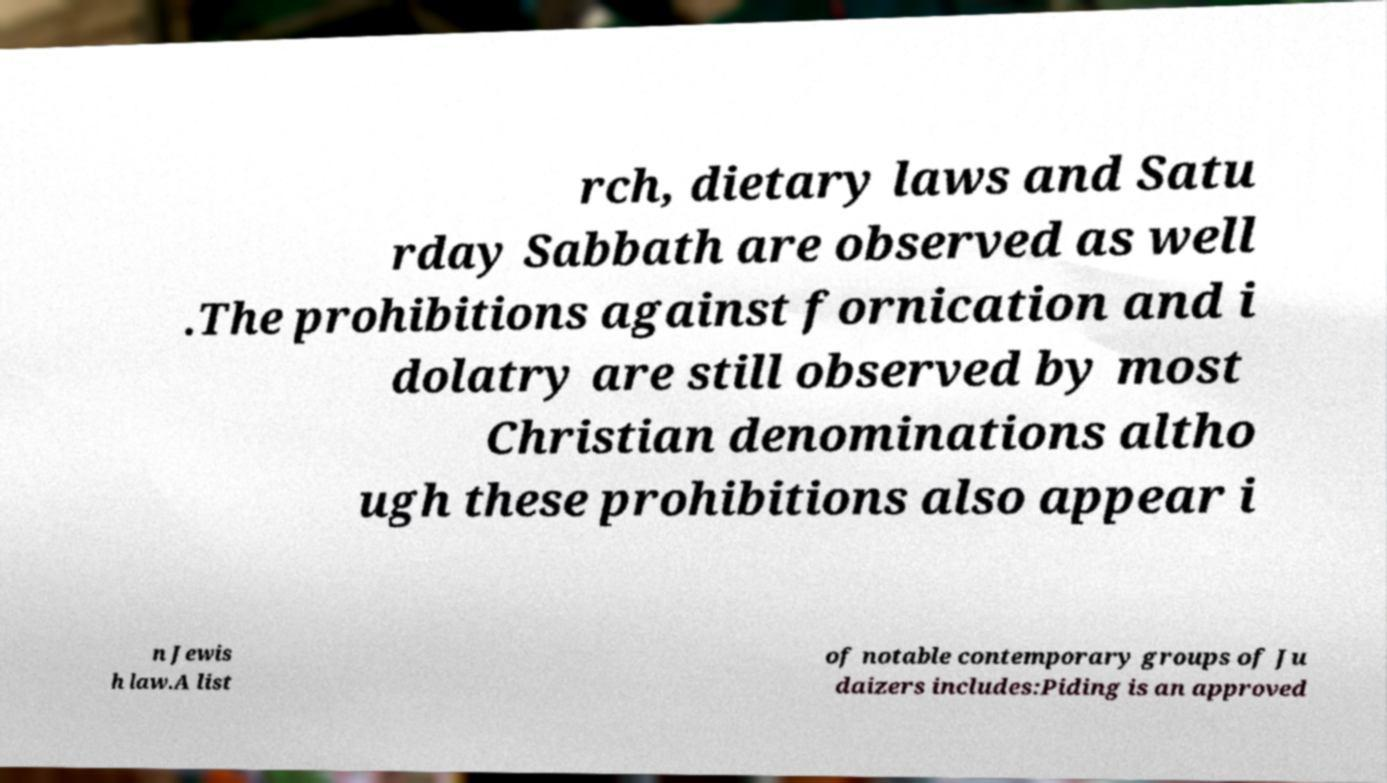I need the written content from this picture converted into text. Can you do that? rch, dietary laws and Satu rday Sabbath are observed as well .The prohibitions against fornication and i dolatry are still observed by most Christian denominations altho ugh these prohibitions also appear i n Jewis h law.A list of notable contemporary groups of Ju daizers includes:Piding is an approved 